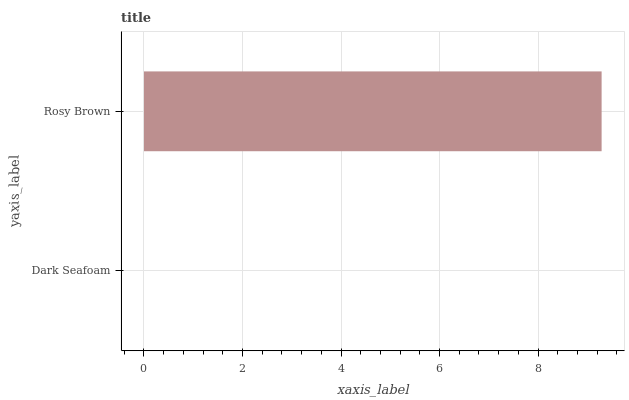Is Dark Seafoam the minimum?
Answer yes or no. Yes. Is Rosy Brown the maximum?
Answer yes or no. Yes. Is Rosy Brown the minimum?
Answer yes or no. No. Is Rosy Brown greater than Dark Seafoam?
Answer yes or no. Yes. Is Dark Seafoam less than Rosy Brown?
Answer yes or no. Yes. Is Dark Seafoam greater than Rosy Brown?
Answer yes or no. No. Is Rosy Brown less than Dark Seafoam?
Answer yes or no. No. Is Rosy Brown the high median?
Answer yes or no. Yes. Is Dark Seafoam the low median?
Answer yes or no. Yes. Is Dark Seafoam the high median?
Answer yes or no. No. Is Rosy Brown the low median?
Answer yes or no. No. 